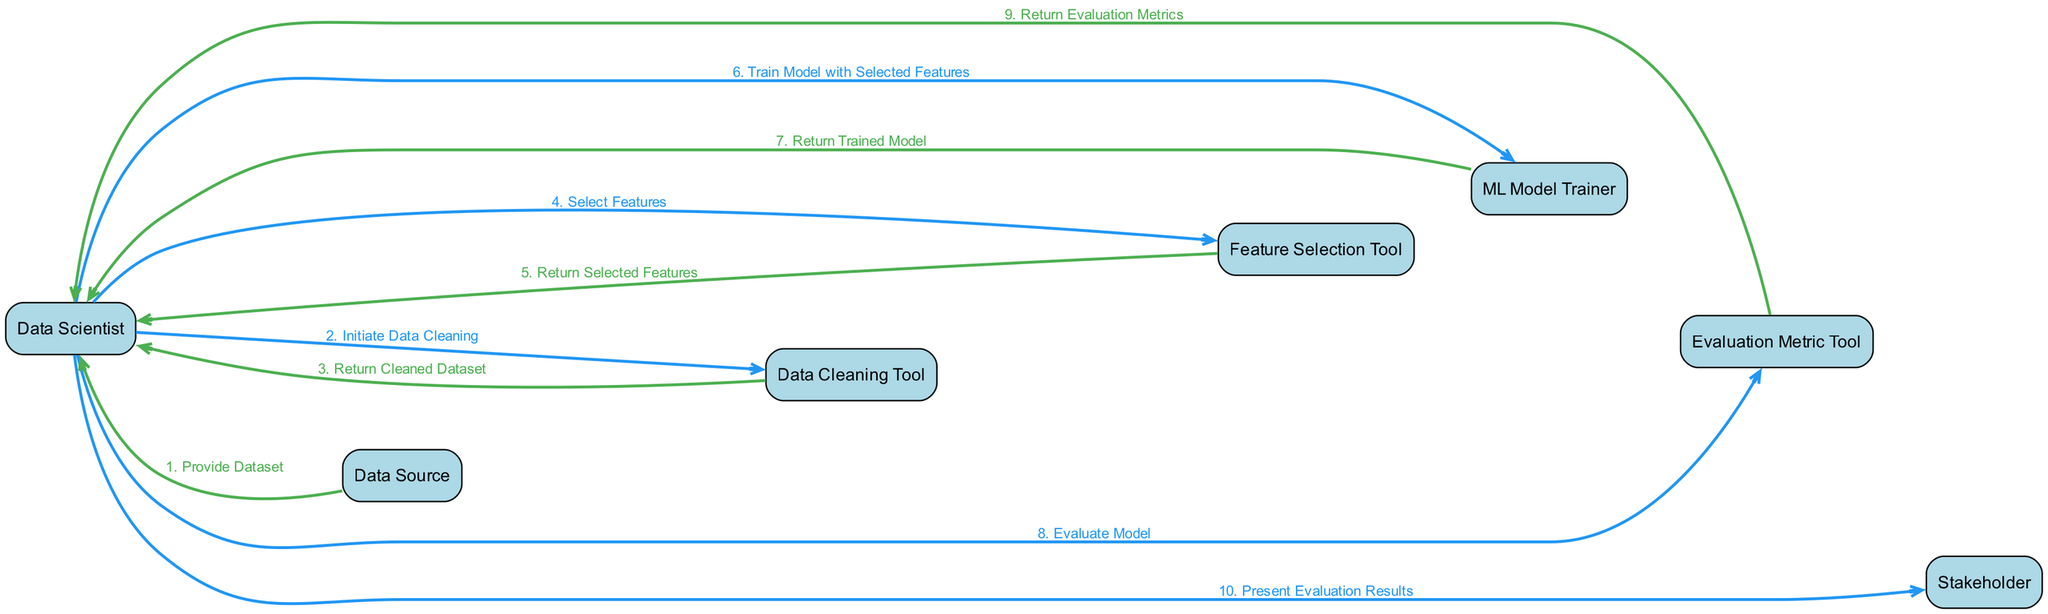What is the first action in the sequence? The first action is initiated by the Data Source, which provides the dataset to the Data Scientist. This is the first message that appears in the sequence of interactions.
Answer: Provide Dataset How many participants are there in the diagram? The diagram lists a total of seven distinct participants involved in the workflow: Data Scientist, Data Source, Data Cleaning Tool, Feature Selection Tool, ML Model Trainer, Evaluation Metric Tool, and Stakeholder.
Answer: 7 Which tool does the Data Scientist use to evaluate the model? The Data Scientist uses the Evaluation Metric Tool to evaluate the trained model. This is indicated by the interaction where the Data Scientist sends a message to the Evaluation Metric Tool for evaluation.
Answer: Evaluation Metric Tool What action follows after the Data Scientist selects features? After the Data Scientist selects features, the next action is training the model with the selected features using the ML Model Trainer. This follows the receipt of the selected features from the Feature Selection Tool.
Answer: Train Model with Selected Features How many messages are exchanged between the Data Scientist and the Evaluation Metric Tool? There are two messages exchanged between the Data Scientist and the Evaluation Metric Tool: one where the Data Scientist requests evaluation and another where the tools return the evaluation metrics.
Answer: 2 Which participant presents the evaluation results to the Stakeholder? The Data Scientist is responsible for presenting the evaluation results to the Stakeholder. This is the final action shown in the sequence, indicating the conclusion of the workflow.
Answer: Data Scientist What is the last action in the sequence? The last action in the sequence involves the Data Scientist presenting the evaluation results to the Stakeholder, marking the end of the workflow from data preparation to model evaluation.
Answer: Present Evaluation Results Which tool returns the cleaned dataset to the Data Scientist? The Data Cleaning Tool is responsible for returning the cleaned dataset back to the Data Scientist after cleaning the initial dataset provided.
Answer: Data Cleaning Tool 